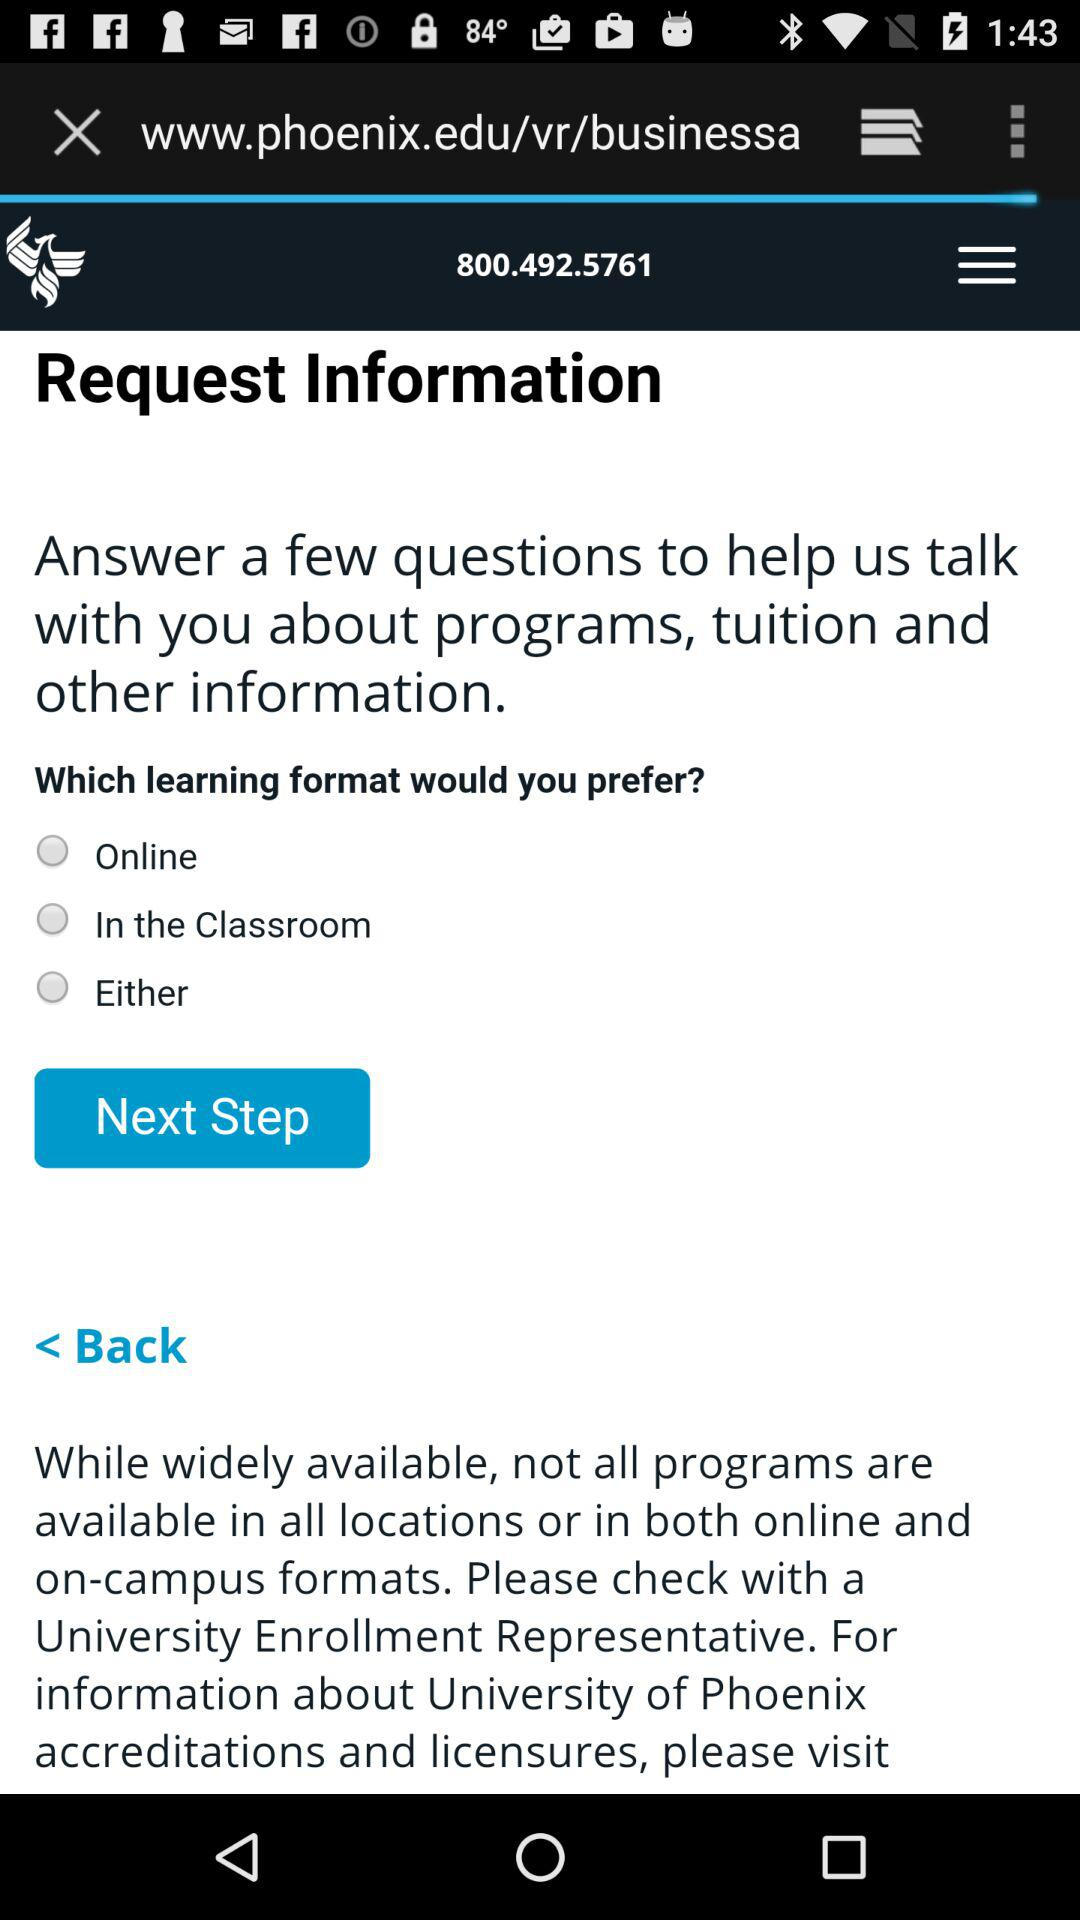How many learning formats are available?
Answer the question using a single word or phrase. 3 